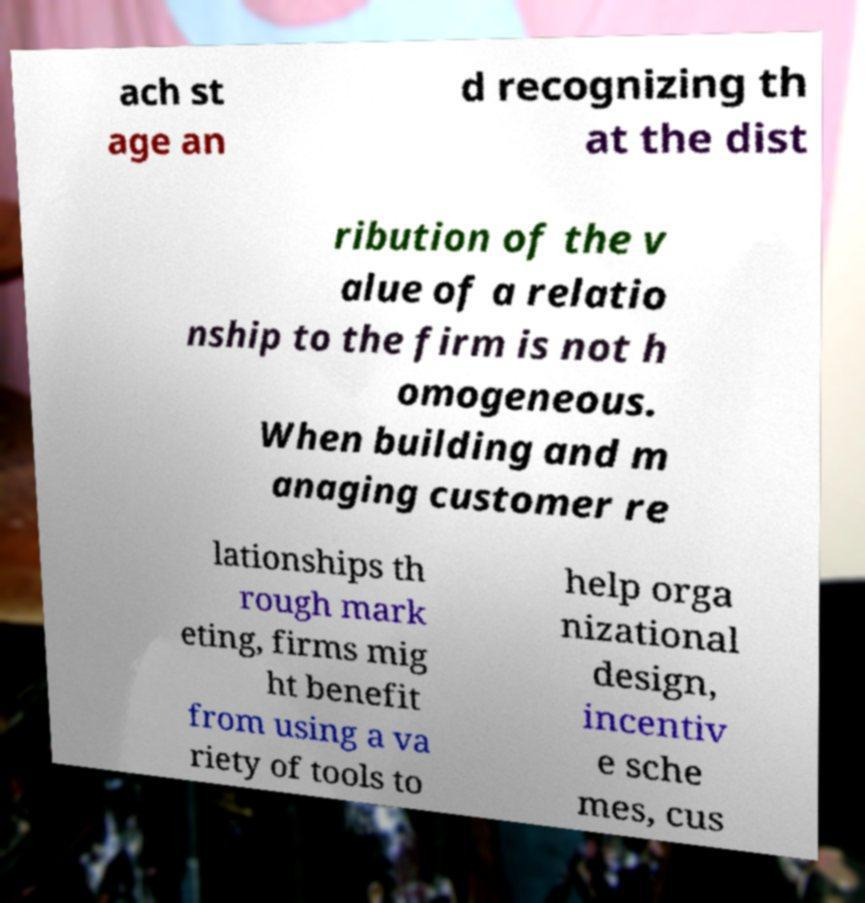Could you extract and type out the text from this image? ach st age an d recognizing th at the dist ribution of the v alue of a relatio nship to the firm is not h omogeneous. When building and m anaging customer re lationships th rough mark eting, firms mig ht benefit from using a va riety of tools to help orga nizational design, incentiv e sche mes, cus 